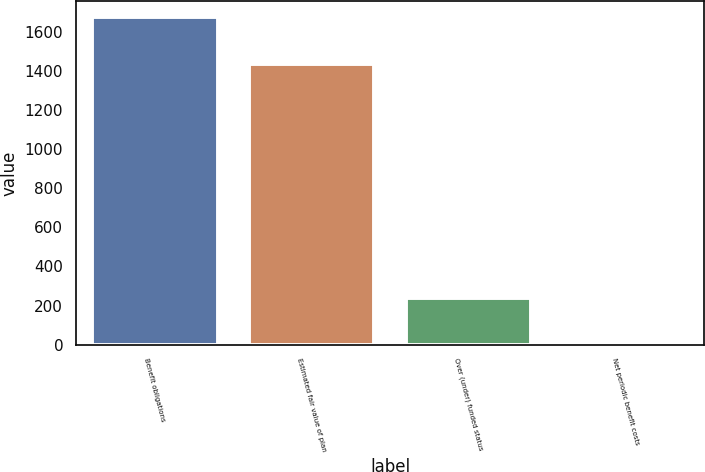Convert chart to OTSL. <chart><loc_0><loc_0><loc_500><loc_500><bar_chart><fcel>Benefit obligations<fcel>Estimated fair value of plan<fcel>Over (under) funded status<fcel>Net periodic benefit costs<nl><fcel>1674<fcel>1434<fcel>240<fcel>10<nl></chart> 